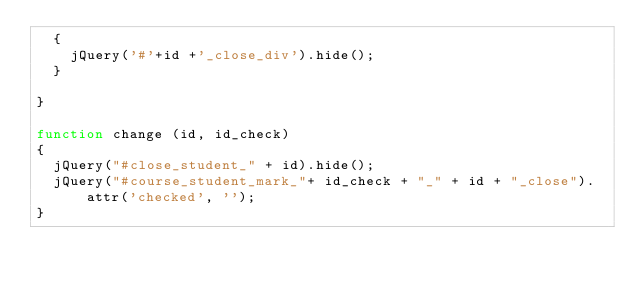Convert code to text. <code><loc_0><loc_0><loc_500><loc_500><_JavaScript_>  {
    jQuery('#'+id +'_close_div').hide();
  }
  
}

function change (id, id_check)
{
  jQuery("#close_student_" + id).hide();
  jQuery("#course_student_mark_"+ id_check + "_" + id + "_close").attr('checked', '');
}</code> 